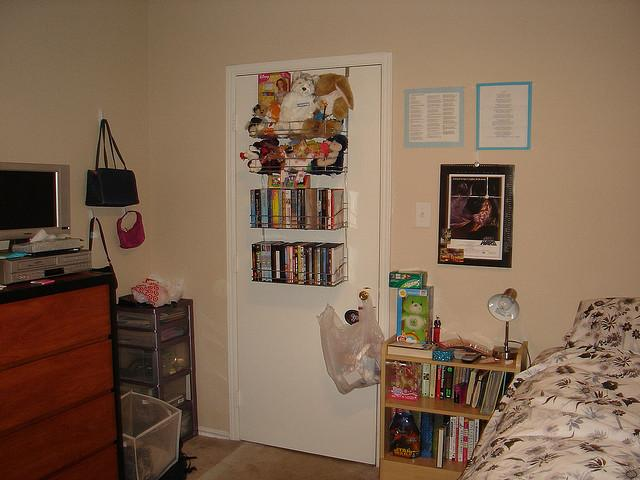What is the plastic bag on the door handle being used to collect? trash 